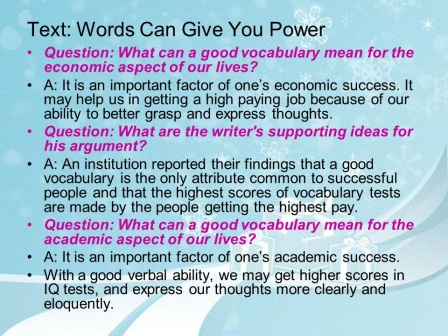What can you infer about the importance of vocabulary from this slide? From this slide, it's evident that a strong vocabulary is deemed crucial for both economic and academic success. The slide highlights that a good vocabulary can aid in getting higher-paying jobs and achieving better academic grades. This suggests a correlation between verbal proficiency and personal achievement. How might improving one's vocabulary impact their day-to-day life? Improving one's vocabulary can significantly enhance daily interactions and personal confidence. With a richer vocabulary, individuals can articulate thoughts more clearly, engage in more meaningful conversations, and understand complex written and spoken content better. This can lead to improved social relationships and greater opportunities in both personal and professional settings. Can you give me a creative scenario where a good vocabulary changed someone's life? Imagine a young woman named Alice, who lived in a quiet village with limited opportunities. Despite her humble beginnings, Alice had a passion for learning and dedicated herself to expanding her vocabulary. One day, she came across a rare job opportunity in a faraway city that required strong communication skills. With her impressive vocabulary, Alice aced the interview and secured the job. Her ability to articulate ideas and connect with people swiftly caught the attention of her employers, leading to rapid promotions. Eventually, Alice's reputation as an eloquent speaker and a sharp thinker attracted the media's attention, propelling her into the spotlight. She became a renowned public speaker, inspiring countless others with her words. Alice's journey from a modest village to international fame exemplifies how a strong vocabulary can unlock unprecedented doors and transform lives.  How might the themes presented in the image apply to someone working in the tech industry? In the tech industry, having a strong vocabulary can greatly enhance one's ability to communicate complex ideas and technical details effectively. This can lead to better collaboration with team members, clearer documentation, and more persuasive presentations. A good vocabulary enables tech professionals to explain concepts to non-technical stakeholders, facilitate smoother client interactions, and contribute to professional growth by making a strong impression during networking and speaking engagements. Thus, the themes of the slide emphasize that a solid vocabulary is as vital in the tech industry as it is in any other field. 